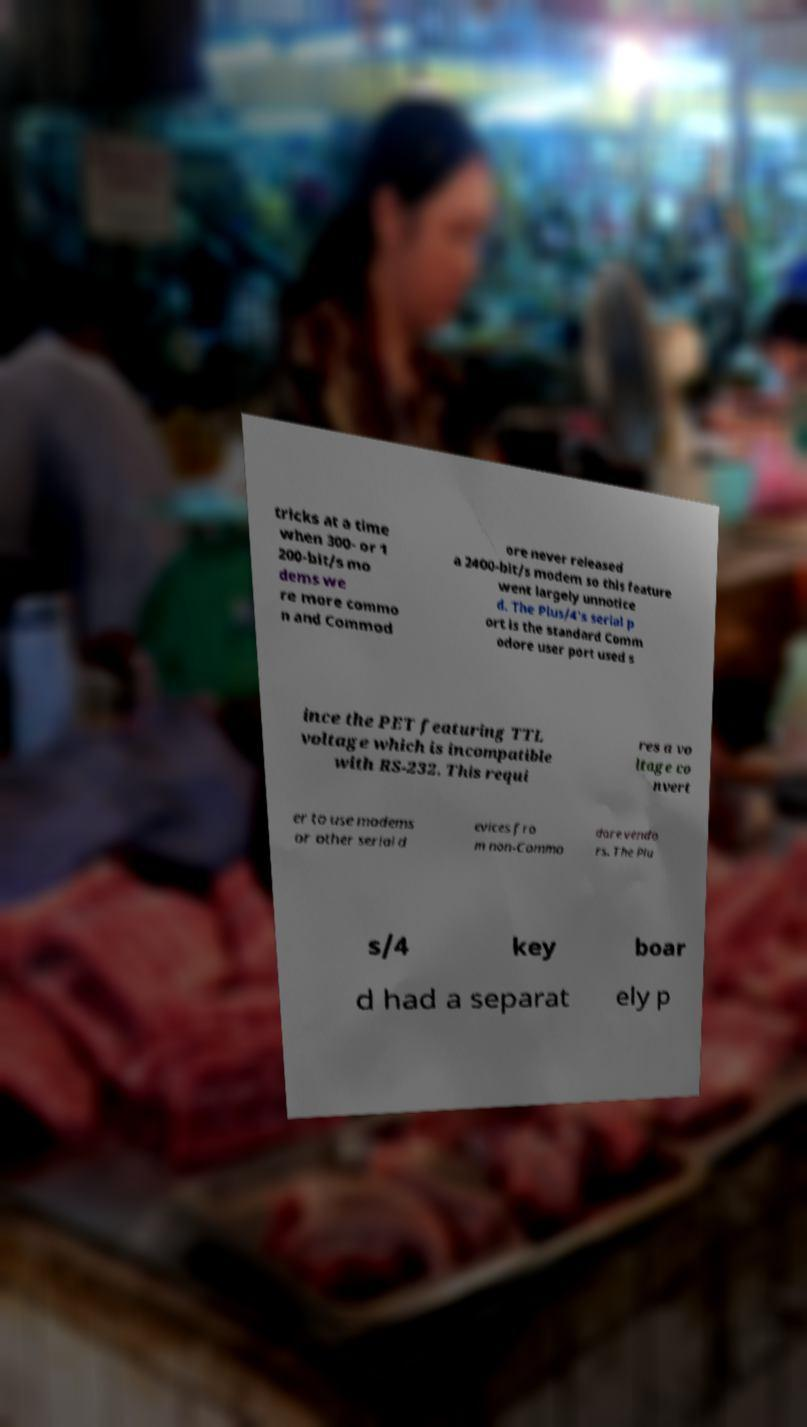Could you extract and type out the text from this image? tricks at a time when 300- or 1 200-bit/s mo dems we re more commo n and Commod ore never released a 2400-bit/s modem so this feature went largely unnotice d. The Plus/4's serial p ort is the standard Comm odore user port used s ince the PET featuring TTL voltage which is incompatible with RS-232. This requi res a vo ltage co nvert er to use modems or other serial d evices fro m non-Commo dore vendo rs. The Plu s/4 key boar d had a separat ely p 